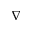Convert formula to latex. <formula><loc_0><loc_0><loc_500><loc_500>\nabla</formula> 